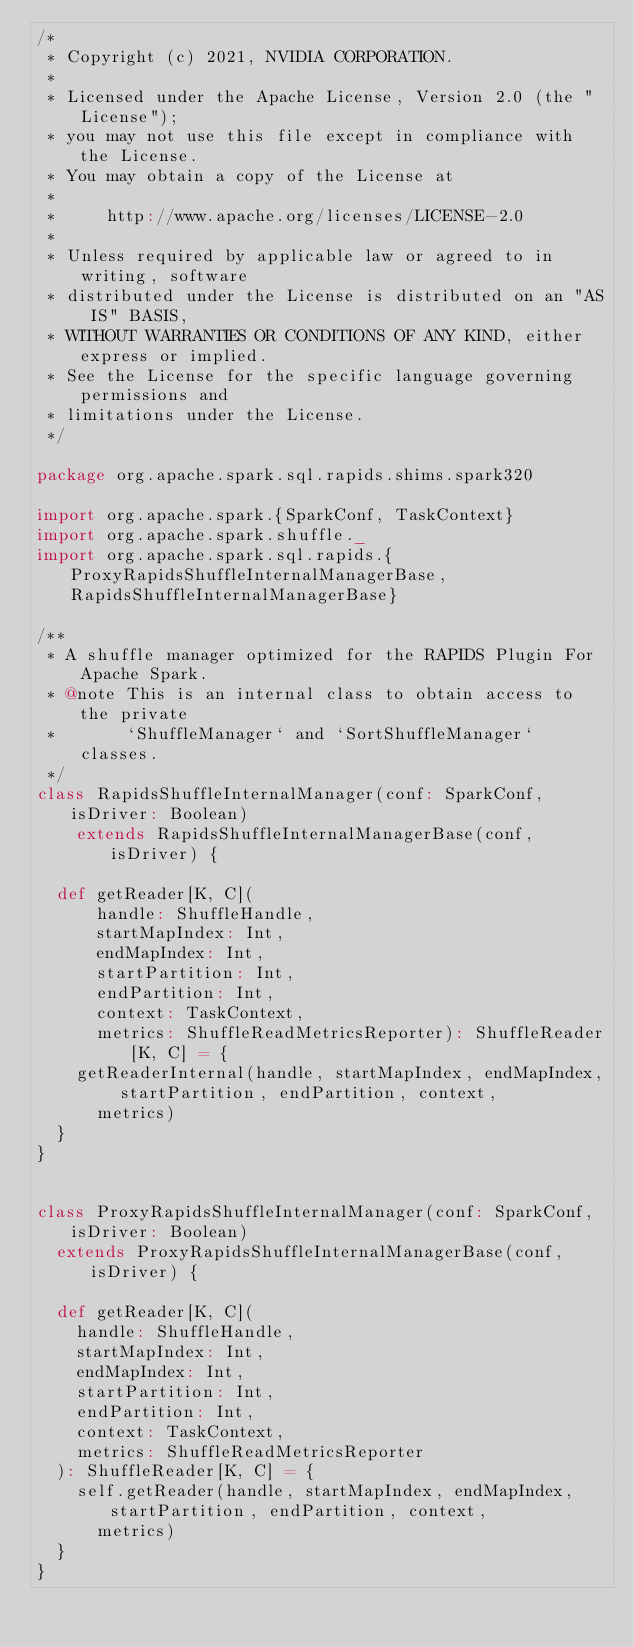<code> <loc_0><loc_0><loc_500><loc_500><_Scala_>/*
 * Copyright (c) 2021, NVIDIA CORPORATION.
 *
 * Licensed under the Apache License, Version 2.0 (the "License");
 * you may not use this file except in compliance with the License.
 * You may obtain a copy of the License at
 *
 *     http://www.apache.org/licenses/LICENSE-2.0
 *
 * Unless required by applicable law or agreed to in writing, software
 * distributed under the License is distributed on an "AS IS" BASIS,
 * WITHOUT WARRANTIES OR CONDITIONS OF ANY KIND, either express or implied.
 * See the License for the specific language governing permissions and
 * limitations under the License.
 */

package org.apache.spark.sql.rapids.shims.spark320

import org.apache.spark.{SparkConf, TaskContext}
import org.apache.spark.shuffle._
import org.apache.spark.sql.rapids.{ProxyRapidsShuffleInternalManagerBase, RapidsShuffleInternalManagerBase}

/**
 * A shuffle manager optimized for the RAPIDS Plugin For Apache Spark.
 * @note This is an internal class to obtain access to the private
 *       `ShuffleManager` and `SortShuffleManager` classes.
 */
class RapidsShuffleInternalManager(conf: SparkConf, isDriver: Boolean)
    extends RapidsShuffleInternalManagerBase(conf, isDriver) {

  def getReader[K, C](
      handle: ShuffleHandle,
      startMapIndex: Int,
      endMapIndex: Int,
      startPartition: Int,
      endPartition: Int,
      context: TaskContext,
      metrics: ShuffleReadMetricsReporter): ShuffleReader[K, C] = {
    getReaderInternal(handle, startMapIndex, endMapIndex, startPartition, endPartition, context,
      metrics)
  }
}


class ProxyRapidsShuffleInternalManager(conf: SparkConf, isDriver: Boolean)
  extends ProxyRapidsShuffleInternalManagerBase(conf, isDriver) {

  def getReader[K, C](
    handle: ShuffleHandle,
    startMapIndex: Int,
    endMapIndex: Int,
    startPartition: Int,
    endPartition: Int,
    context: TaskContext,
    metrics: ShuffleReadMetricsReporter
  ): ShuffleReader[K, C] = {
    self.getReader(handle, startMapIndex, endMapIndex, startPartition, endPartition, context,
      metrics)
  }
}</code> 